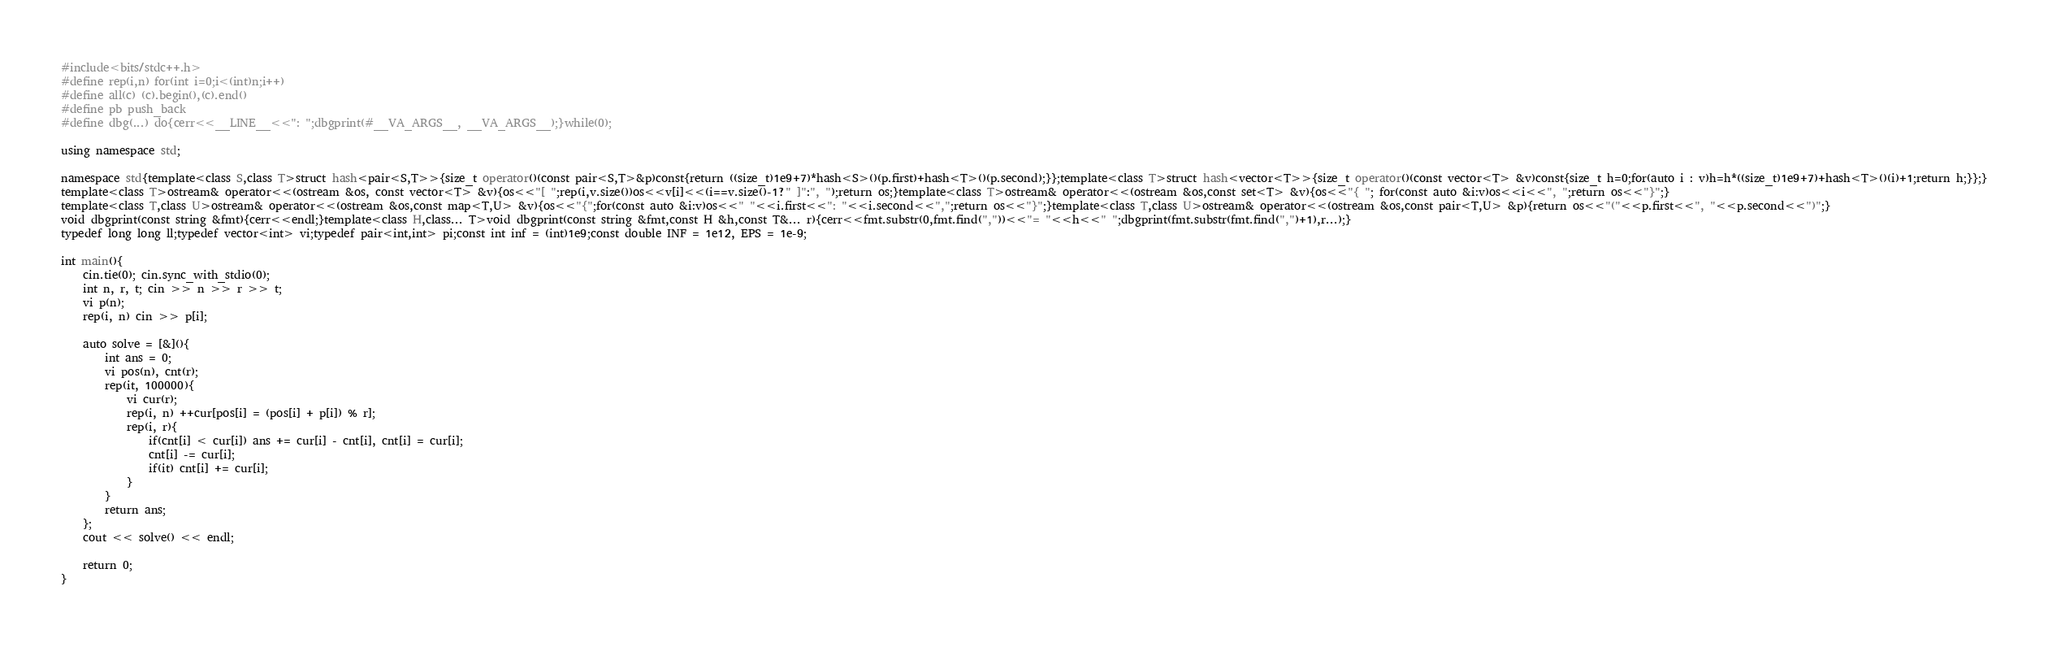<code> <loc_0><loc_0><loc_500><loc_500><_C++_>#include<bits/stdc++.h>
#define rep(i,n) for(int i=0;i<(int)n;i++)
#define all(c) (c).begin(),(c).end()
#define pb push_back
#define dbg(...) do{cerr<<__LINE__<<": ";dbgprint(#__VA_ARGS__, __VA_ARGS__);}while(0);

using namespace std;

namespace std{template<class S,class T>struct hash<pair<S,T>>{size_t operator()(const pair<S,T>&p)const{return ((size_t)1e9+7)*hash<S>()(p.first)+hash<T>()(p.second);}};template<class T>struct hash<vector<T>>{size_t operator()(const vector<T> &v)const{size_t h=0;for(auto i : v)h=h*((size_t)1e9+7)+hash<T>()(i)+1;return h;}};}
template<class T>ostream& operator<<(ostream &os, const vector<T> &v){os<<"[ ";rep(i,v.size())os<<v[i]<<(i==v.size()-1?" ]":", ");return os;}template<class T>ostream& operator<<(ostream &os,const set<T> &v){os<<"{ "; for(const auto &i:v)os<<i<<", ";return os<<"}";}
template<class T,class U>ostream& operator<<(ostream &os,const map<T,U> &v){os<<"{";for(const auto &i:v)os<<" "<<i.first<<": "<<i.second<<",";return os<<"}";}template<class T,class U>ostream& operator<<(ostream &os,const pair<T,U> &p){return os<<"("<<p.first<<", "<<p.second<<")";}
void dbgprint(const string &fmt){cerr<<endl;}template<class H,class... T>void dbgprint(const string &fmt,const H &h,const T&... r){cerr<<fmt.substr(0,fmt.find(","))<<"= "<<h<<" ";dbgprint(fmt.substr(fmt.find(",")+1),r...);}
typedef long long ll;typedef vector<int> vi;typedef pair<int,int> pi;const int inf = (int)1e9;const double INF = 1e12, EPS = 1e-9;

int main(){
	cin.tie(0); cin.sync_with_stdio(0);
	int n, r, t; cin >> n >> r >> t;
	vi p(n);
	rep(i, n) cin >> p[i];
	
	auto solve = [&](){
		int ans = 0;
		vi pos(n), cnt(r);
		rep(it, 100000){
			vi cur(r);
			rep(i, n) ++cur[pos[i] = (pos[i] + p[i]) % r];
			rep(i, r){
				if(cnt[i] < cur[i]) ans += cur[i] - cnt[i], cnt[i] = cur[i];
				cnt[i] -= cur[i];
				if(it) cnt[i] += cur[i];
			}
		}
		return ans;
	};
	cout << solve() << endl;
	
	return 0;
}
</code> 